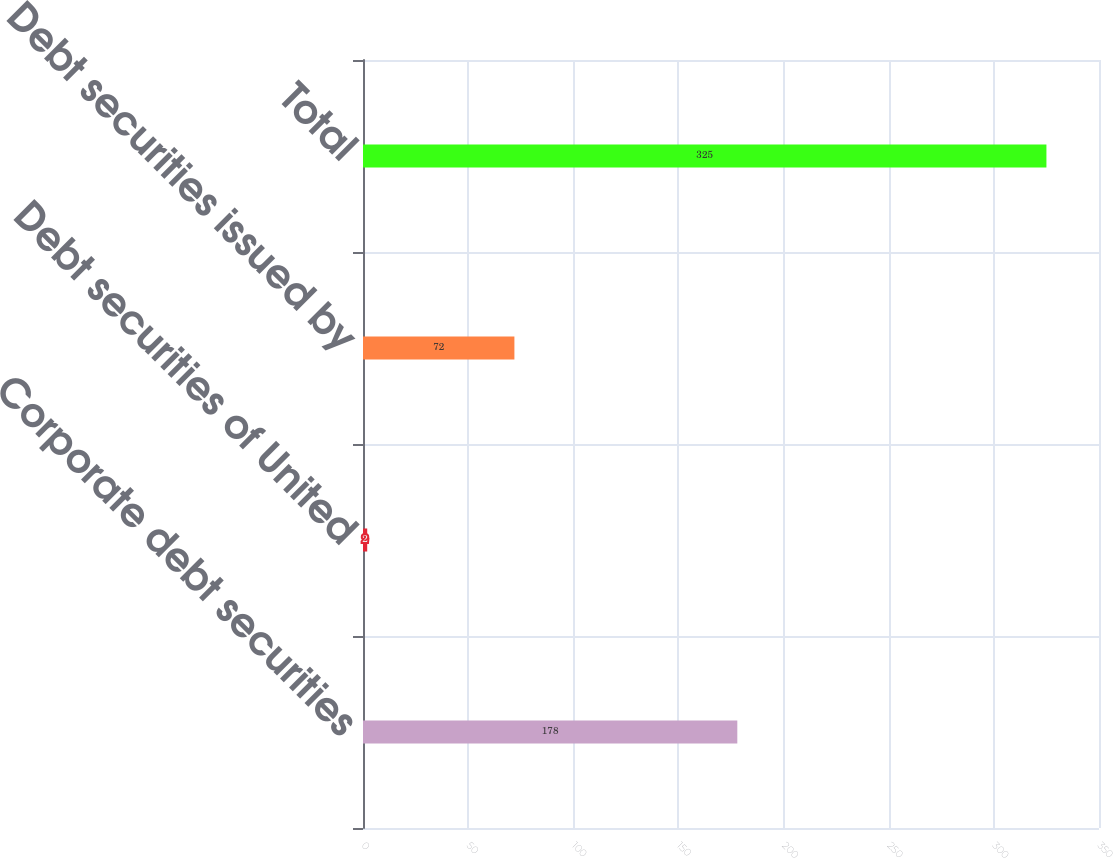Convert chart to OTSL. <chart><loc_0><loc_0><loc_500><loc_500><bar_chart><fcel>Corporate debt securities<fcel>Debt securities of United<fcel>Debt securities issued by<fcel>Total<nl><fcel>178<fcel>2<fcel>72<fcel>325<nl></chart> 